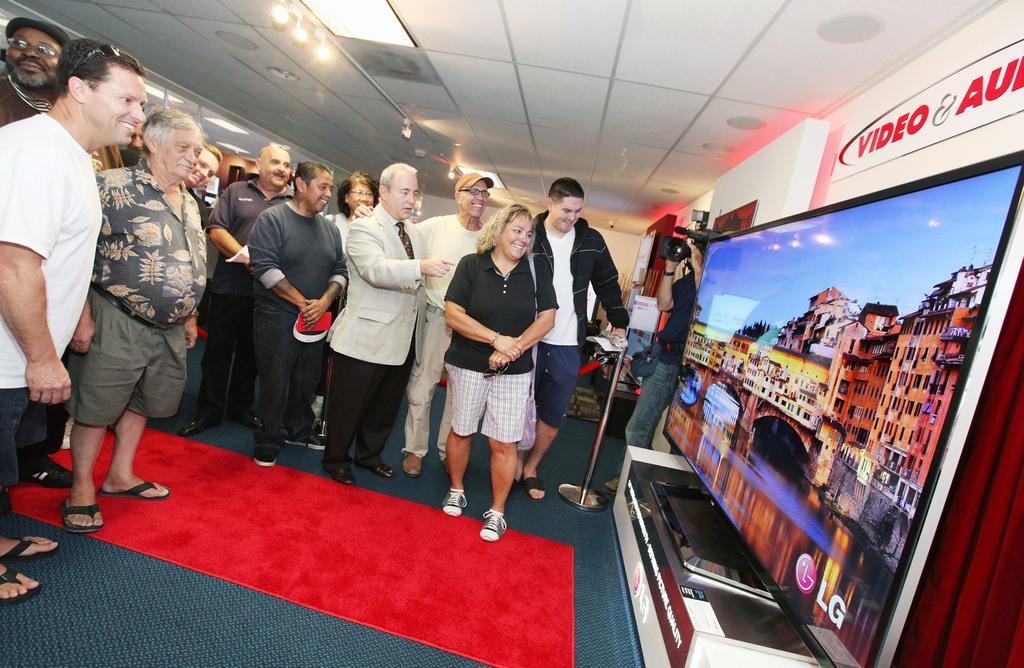In one or two sentences, can you explain what this image depicts? In the foreground, I can see a group of people are standing on the floor in front of a TV and I can see some objects. In the background, I can see a person is holding a camera in hand, lights on a rooftop and a text on a wall. This image taken, maybe in a hall. 